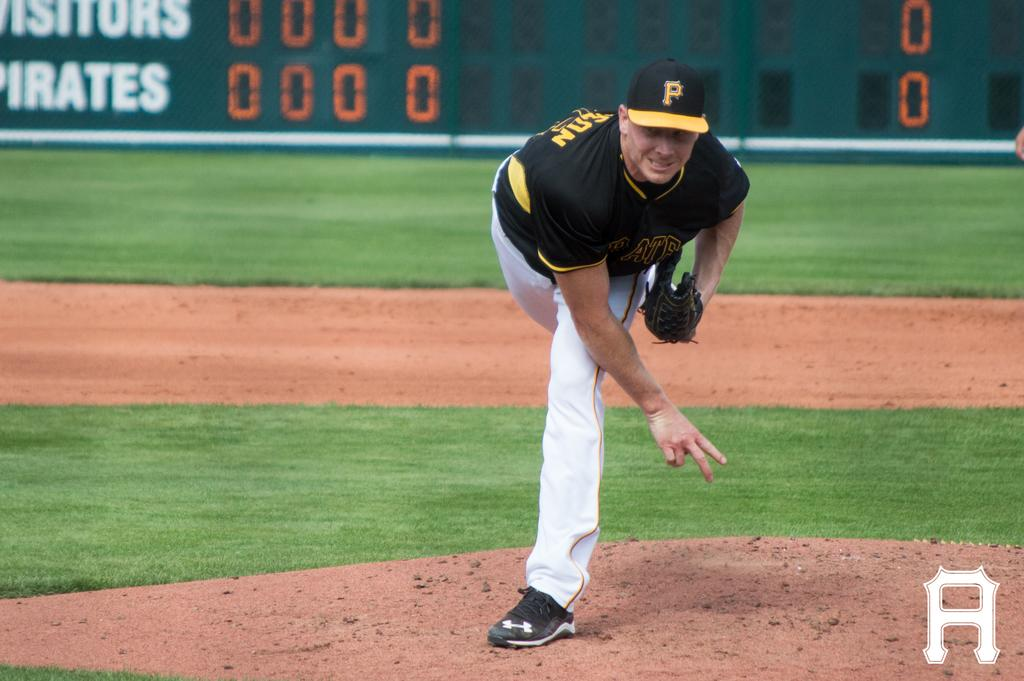<image>
Describe the image concisely. pittsburgh pirates pitcher after throwing the ball and scoreboard behind him showing score of 0 to 0 